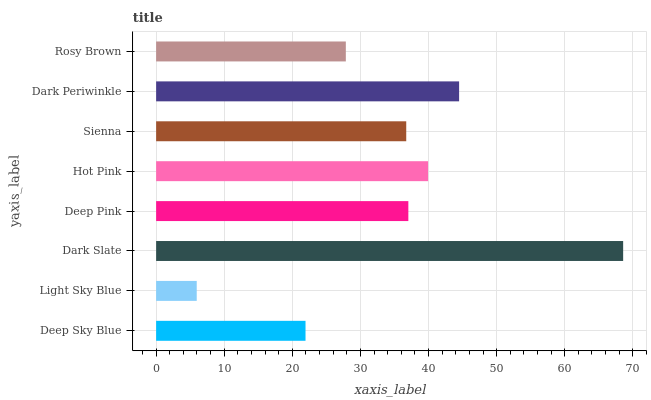Is Light Sky Blue the minimum?
Answer yes or no. Yes. Is Dark Slate the maximum?
Answer yes or no. Yes. Is Dark Slate the minimum?
Answer yes or no. No. Is Light Sky Blue the maximum?
Answer yes or no. No. Is Dark Slate greater than Light Sky Blue?
Answer yes or no. Yes. Is Light Sky Blue less than Dark Slate?
Answer yes or no. Yes. Is Light Sky Blue greater than Dark Slate?
Answer yes or no. No. Is Dark Slate less than Light Sky Blue?
Answer yes or no. No. Is Deep Pink the high median?
Answer yes or no. Yes. Is Sienna the low median?
Answer yes or no. Yes. Is Hot Pink the high median?
Answer yes or no. No. Is Light Sky Blue the low median?
Answer yes or no. No. 